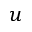Convert formula to latex. <formula><loc_0><loc_0><loc_500><loc_500>u</formula> 